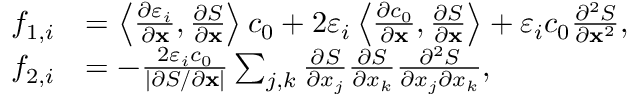Convert formula to latex. <formula><loc_0><loc_0><loc_500><loc_500>\begin{array} { r l } { f _ { 1 , i } } & { = \left \langle \frac { \partial \varepsilon _ { i } } { \partial x } , \frac { \partial S } { \partial x } \right \rangle c _ { 0 } + 2 \varepsilon _ { i } \left \langle \frac { \partial c _ { 0 } } { \partial x } , \frac { \partial S } { \partial x } \right \rangle + \varepsilon _ { i } c _ { 0 } \frac { \partial ^ { 2 } S } { \partial x ^ { 2 } } , } \\ { f _ { 2 , i } } & { = - \frac { 2 \varepsilon _ { i } c _ { 0 } } { | \partial S / \partial x | } \sum _ { j , k } \frac { \partial S } { \partial x _ { j } } \frac { \partial S } { \partial x _ { k } } \frac { \partial ^ { 2 } S } { \partial x _ { j } \partial x _ { k } } , } \end{array}</formula> 